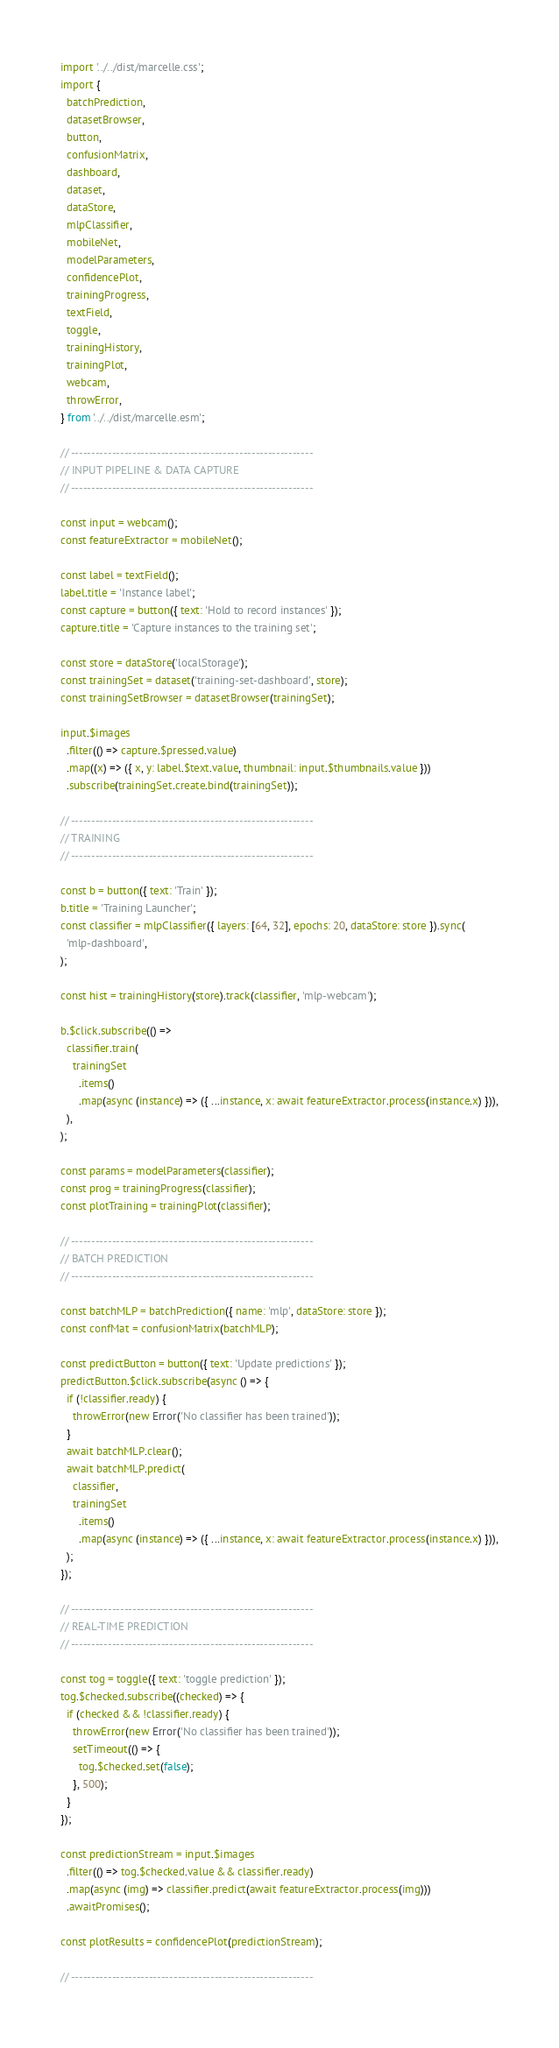<code> <loc_0><loc_0><loc_500><loc_500><_JavaScript_>import '../../dist/marcelle.css';
import {
  batchPrediction,
  datasetBrowser,
  button,
  confusionMatrix,
  dashboard,
  dataset,
  dataStore,
  mlpClassifier,
  mobileNet,
  modelParameters,
  confidencePlot,
  trainingProgress,
  textField,
  toggle,
  trainingHistory,
  trainingPlot,
  webcam,
  throwError,
} from '../../dist/marcelle.esm';

// -----------------------------------------------------------
// INPUT PIPELINE & DATA CAPTURE
// -----------------------------------------------------------

const input = webcam();
const featureExtractor = mobileNet();

const label = textField();
label.title = 'Instance label';
const capture = button({ text: 'Hold to record instances' });
capture.title = 'Capture instances to the training set';

const store = dataStore('localStorage');
const trainingSet = dataset('training-set-dashboard', store);
const trainingSetBrowser = datasetBrowser(trainingSet);

input.$images
  .filter(() => capture.$pressed.value)
  .map((x) => ({ x, y: label.$text.value, thumbnail: input.$thumbnails.value }))
  .subscribe(trainingSet.create.bind(trainingSet));

// -----------------------------------------------------------
// TRAINING
// -----------------------------------------------------------

const b = button({ text: 'Train' });
b.title = 'Training Launcher';
const classifier = mlpClassifier({ layers: [64, 32], epochs: 20, dataStore: store }).sync(
  'mlp-dashboard',
);

const hist = trainingHistory(store).track(classifier, 'mlp-webcam');

b.$click.subscribe(() =>
  classifier.train(
    trainingSet
      .items()
      .map(async (instance) => ({ ...instance, x: await featureExtractor.process(instance.x) })),
  ),
);

const params = modelParameters(classifier);
const prog = trainingProgress(classifier);
const plotTraining = trainingPlot(classifier);

// -----------------------------------------------------------
// BATCH PREDICTION
// -----------------------------------------------------------

const batchMLP = batchPrediction({ name: 'mlp', dataStore: store });
const confMat = confusionMatrix(batchMLP);

const predictButton = button({ text: 'Update predictions' });
predictButton.$click.subscribe(async () => {
  if (!classifier.ready) {
    throwError(new Error('No classifier has been trained'));
  }
  await batchMLP.clear();
  await batchMLP.predict(
    classifier,
    trainingSet
      .items()
      .map(async (instance) => ({ ...instance, x: await featureExtractor.process(instance.x) })),
  );
});

// -----------------------------------------------------------
// REAL-TIME PREDICTION
// -----------------------------------------------------------

const tog = toggle({ text: 'toggle prediction' });
tog.$checked.subscribe((checked) => {
  if (checked && !classifier.ready) {
    throwError(new Error('No classifier has been trained'));
    setTimeout(() => {
      tog.$checked.set(false);
    }, 500);
  }
});

const predictionStream = input.$images
  .filter(() => tog.$checked.value && classifier.ready)
  .map(async (img) => classifier.predict(await featureExtractor.process(img)))
  .awaitPromises();

const plotResults = confidencePlot(predictionStream);

// -----------------------------------------------------------</code> 